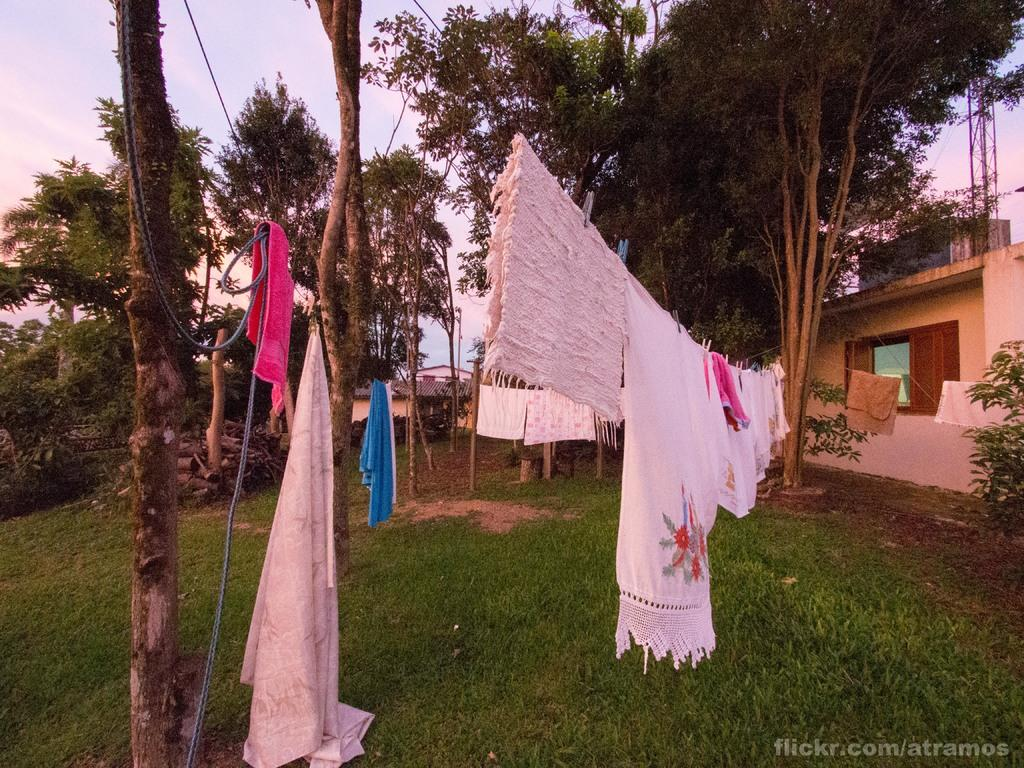What is hanging on the ropes in the image? There are clothes on the ropes in the image. What type of terrain is visible in the foreground of the image? There is a grassland in the foreground of the image. What can be seen in the background of the image? There are trees, houses, and the sky visible in the background of the image. Can you tell me how the team is attempting to talk to the grass in the image? There is no team or grass communication present in the image; it features clothes hanging on ropes, a grassland, trees, houses, and the sky. 